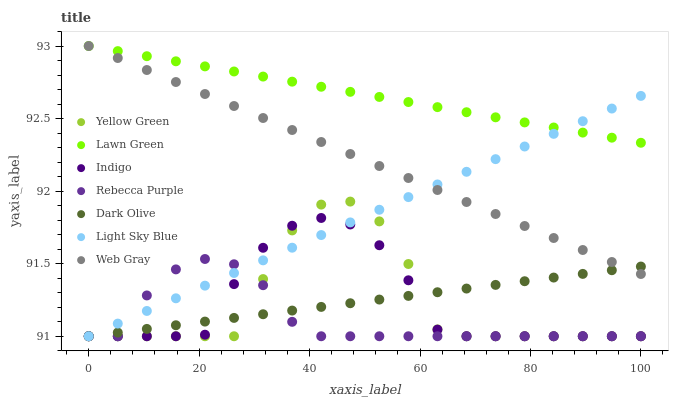Does Rebecca Purple have the minimum area under the curve?
Answer yes or no. Yes. Does Lawn Green have the maximum area under the curve?
Answer yes or no. Yes. Does Web Gray have the minimum area under the curve?
Answer yes or no. No. Does Web Gray have the maximum area under the curve?
Answer yes or no. No. Is Dark Olive the smoothest?
Answer yes or no. Yes. Is Yellow Green the roughest?
Answer yes or no. Yes. Is Web Gray the smoothest?
Answer yes or no. No. Is Web Gray the roughest?
Answer yes or no. No. Does Indigo have the lowest value?
Answer yes or no. Yes. Does Web Gray have the lowest value?
Answer yes or no. No. Does Web Gray have the highest value?
Answer yes or no. Yes. Does Indigo have the highest value?
Answer yes or no. No. Is Yellow Green less than Lawn Green?
Answer yes or no. Yes. Is Lawn Green greater than Rebecca Purple?
Answer yes or no. Yes. Does Web Gray intersect Light Sky Blue?
Answer yes or no. Yes. Is Web Gray less than Light Sky Blue?
Answer yes or no. No. Is Web Gray greater than Light Sky Blue?
Answer yes or no. No. Does Yellow Green intersect Lawn Green?
Answer yes or no. No. 